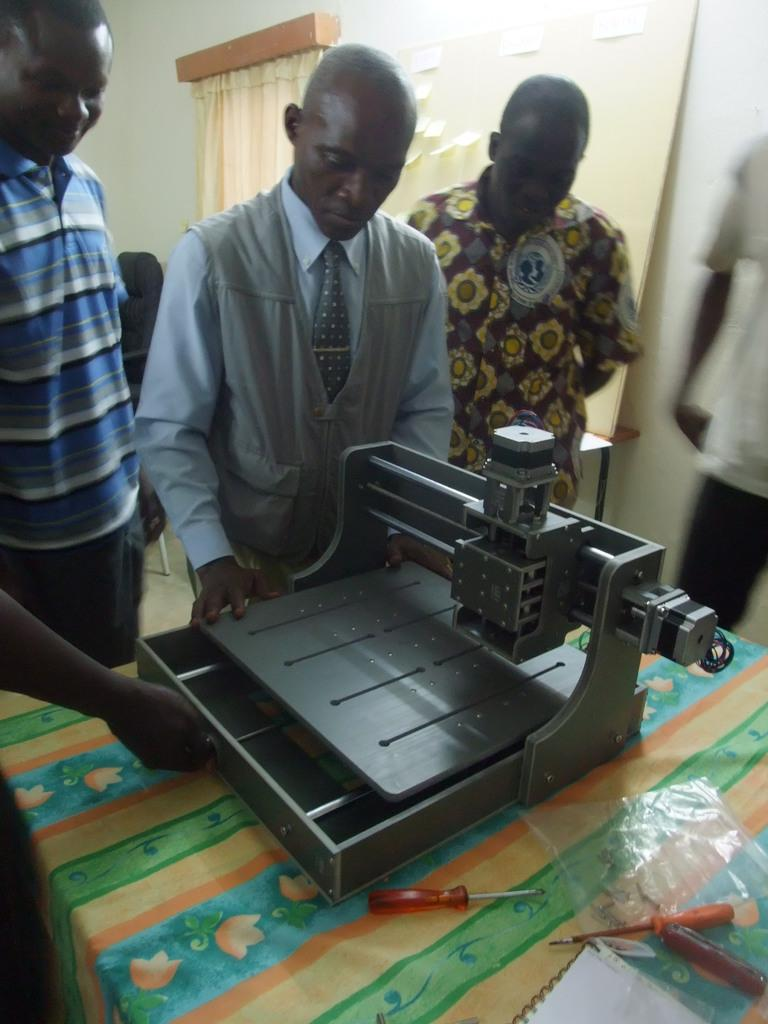Who or what can be seen in the image? There are people in the image. What type of equipment is present in the image? There is a machine and tools in the image. What is covering something in the image? There is a cover in the image. What is on the table in the image? There is a book on the table. What can be seen in the background of the image? There is a wall, a curtain, and stickers on a board in the background of the image. What type of root can be seen growing on the edge of the table in the image? There is no root visible in the image, nor is there any indication of growth on the table's edge. 